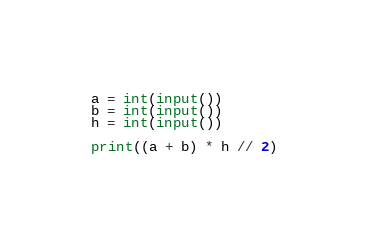<code> <loc_0><loc_0><loc_500><loc_500><_Python_>a = int(input())
b = int(input())
h = int(input())

print((a + b) * h // 2)
</code> 